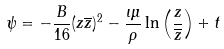Convert formula to latex. <formula><loc_0><loc_0><loc_500><loc_500>\psi = - \frac { B } { 1 6 } ( z \overline { z } ) ^ { 2 } - \frac { \iota \mu } { \rho } \ln \left ( \frac { z } { \overline { z } } \right ) + t</formula> 